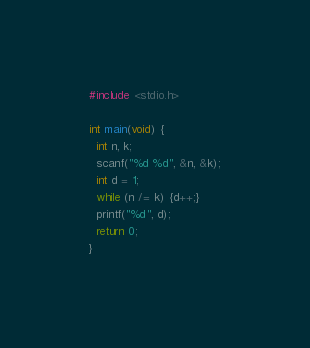<code> <loc_0><loc_0><loc_500><loc_500><_C_>#include <stdio.h>

int main(void) {
  int n, k;
  scanf("%d %d", &n, &k);
  int d = 1;
  while (n /= k) {d++;}
  printf("%d", d);
  return 0;
}</code> 